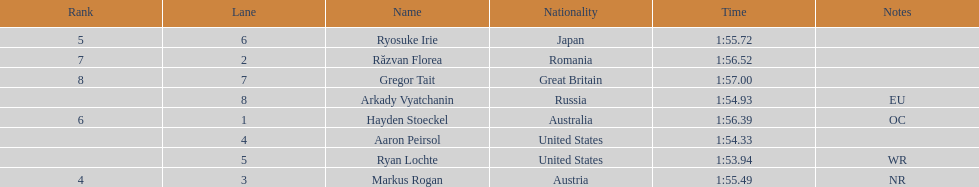Did austria or russia rank higher? Russia. 